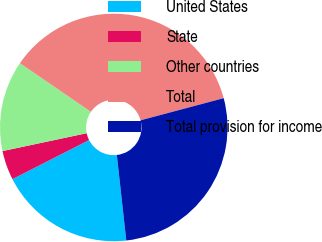Convert chart. <chart><loc_0><loc_0><loc_500><loc_500><pie_chart><fcel>United States<fcel>State<fcel>Other countries<fcel>Total<fcel>Total provision for income<nl><fcel>19.25%<fcel>4.18%<fcel>12.88%<fcel>36.31%<fcel>27.39%<nl></chart> 